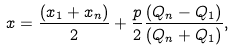<formula> <loc_0><loc_0><loc_500><loc_500>x = \frac { ( x _ { 1 } + x _ { n } ) } { 2 } + \frac { p } { 2 } \frac { ( Q _ { n } - Q _ { 1 } ) } { ( Q _ { n } + Q _ { 1 } ) } ,</formula> 